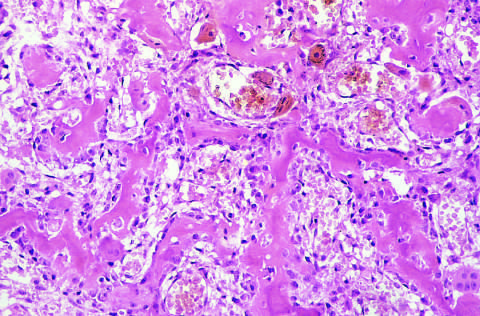what is composed of haphazardly interconnecting trabeculae of woven bone that are rimmed by prominent osteoblasts?
Answer the question using a single word or phrase. Osteoid osteoma 